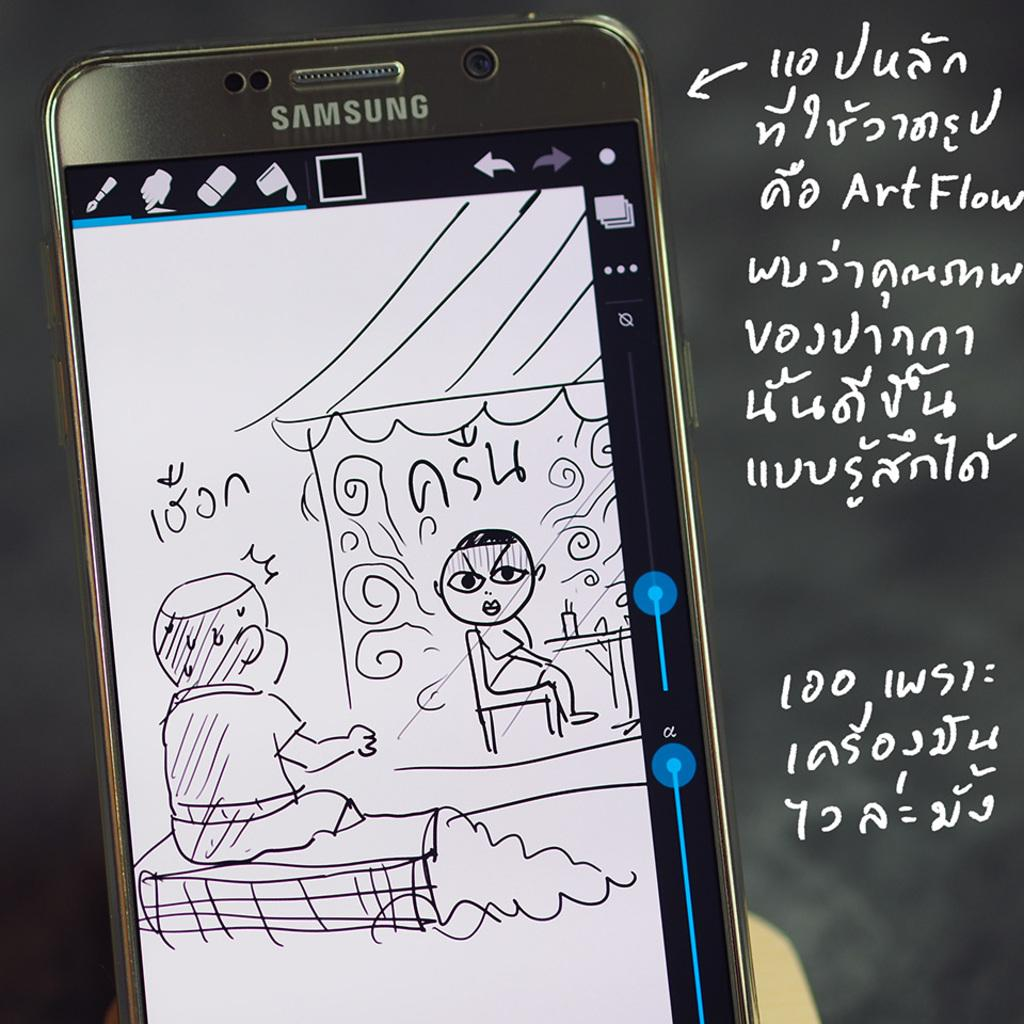<image>
Describe the image concisely. A Samsung smartphone with a comic sketch displayed.. 